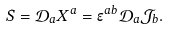<formula> <loc_0><loc_0><loc_500><loc_500>S = \mathcal { D } _ { a } X ^ { a } = \epsilon ^ { a b } \mathcal { D } _ { a } \mathcal { J } _ { b } .</formula> 